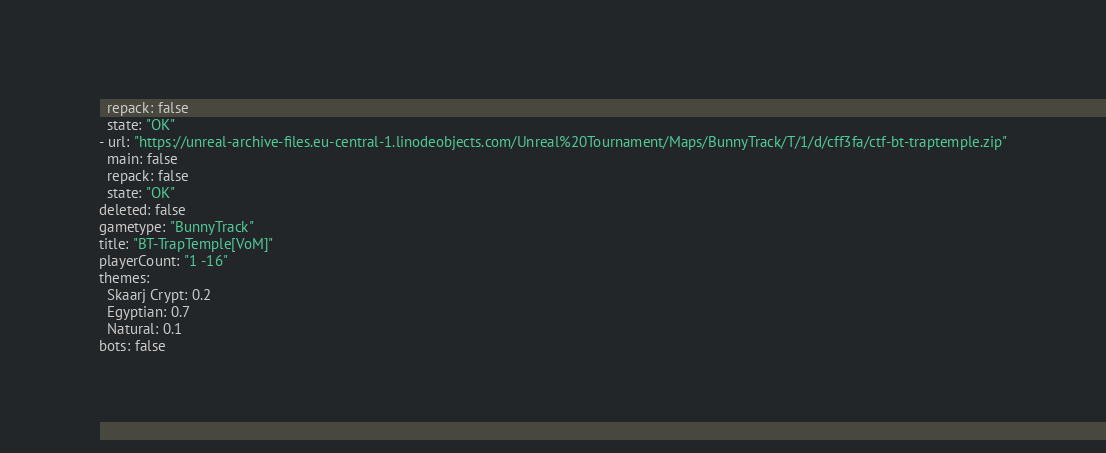Convert code to text. <code><loc_0><loc_0><loc_500><loc_500><_YAML_>  repack: false
  state: "OK"
- url: "https://unreal-archive-files.eu-central-1.linodeobjects.com/Unreal%20Tournament/Maps/BunnyTrack/T/1/d/cff3fa/ctf-bt-traptemple.zip"
  main: false
  repack: false
  state: "OK"
deleted: false
gametype: "BunnyTrack"
title: "BT-TrapTemple[VoM]"
playerCount: "1 -16"
themes:
  Skaarj Crypt: 0.2
  Egyptian: 0.7
  Natural: 0.1
bots: false
</code> 